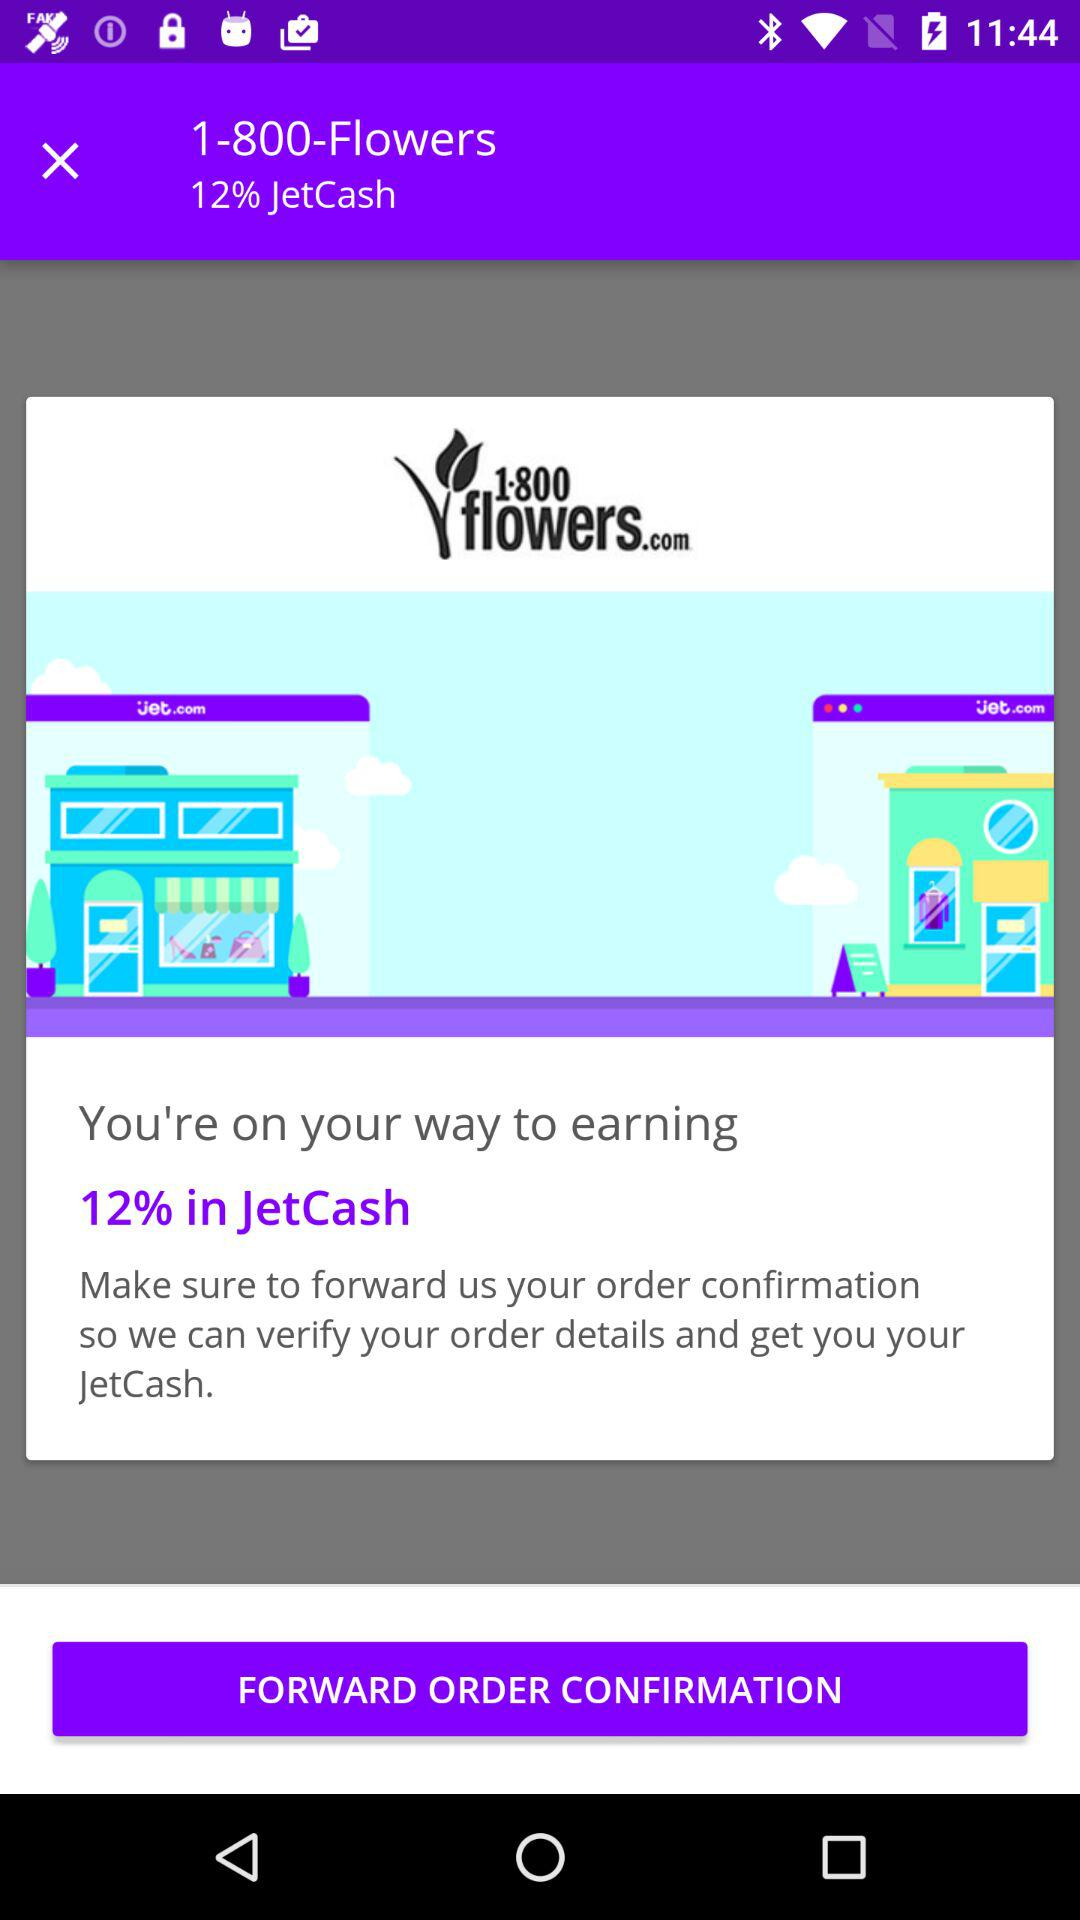How much JetCash is the user on track to earn?
Answer the question using a single word or phrase. 12% 